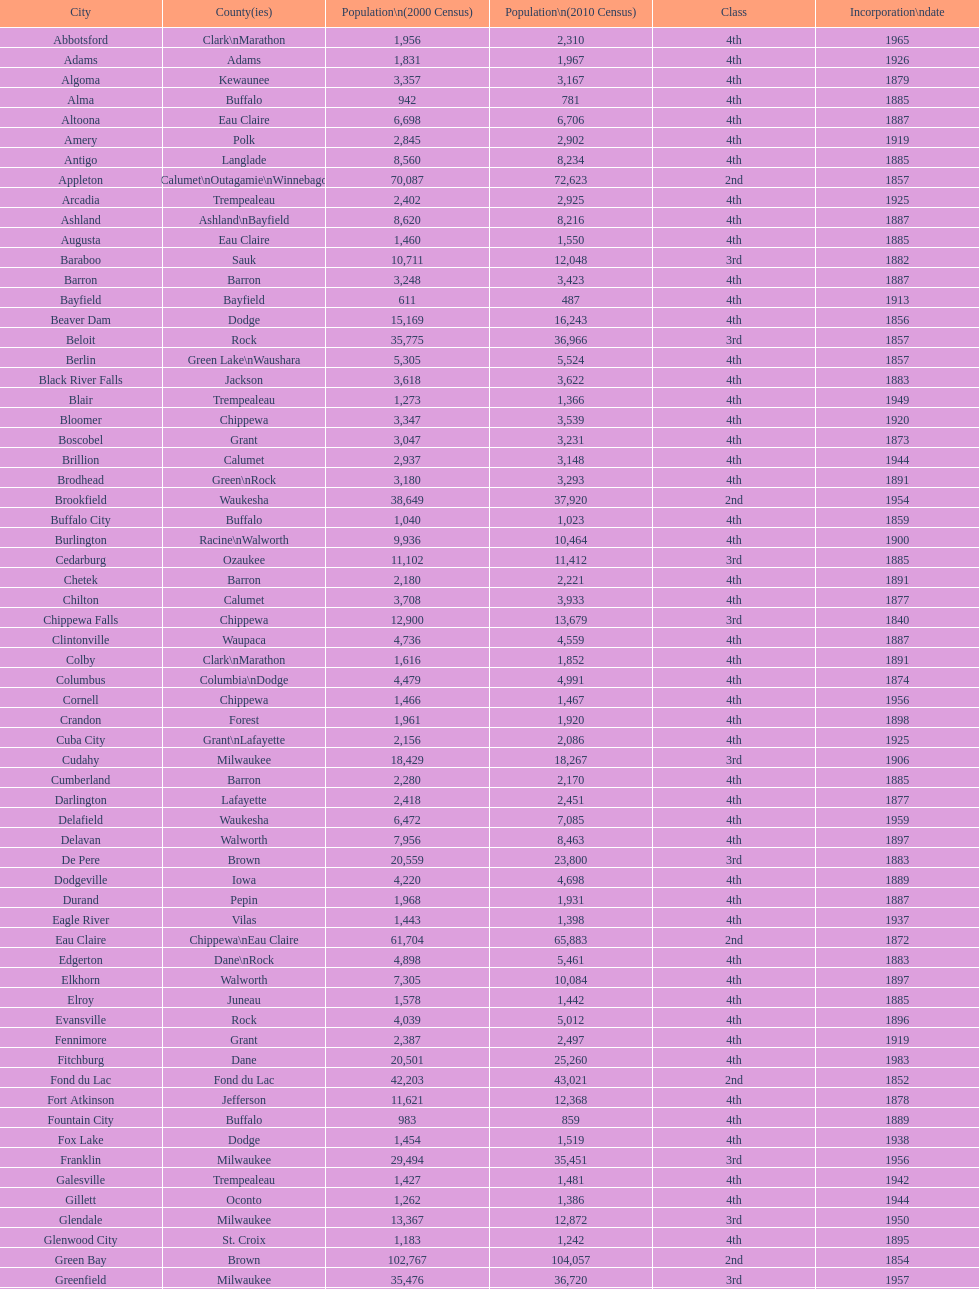Would you mind parsing the complete table? {'header': ['City', 'County(ies)', 'Population\\n(2000 Census)', 'Population\\n(2010 Census)', 'Class', 'Incorporation\\ndate'], 'rows': [['Abbotsford', 'Clark\\nMarathon', '1,956', '2,310', '4th', '1965'], ['Adams', 'Adams', '1,831', '1,967', '4th', '1926'], ['Algoma', 'Kewaunee', '3,357', '3,167', '4th', '1879'], ['Alma', 'Buffalo', '942', '781', '4th', '1885'], ['Altoona', 'Eau Claire', '6,698', '6,706', '4th', '1887'], ['Amery', 'Polk', '2,845', '2,902', '4th', '1919'], ['Antigo', 'Langlade', '8,560', '8,234', '4th', '1885'], ['Appleton', 'Calumet\\nOutagamie\\nWinnebago', '70,087', '72,623', '2nd', '1857'], ['Arcadia', 'Trempealeau', '2,402', '2,925', '4th', '1925'], ['Ashland', 'Ashland\\nBayfield', '8,620', '8,216', '4th', '1887'], ['Augusta', 'Eau Claire', '1,460', '1,550', '4th', '1885'], ['Baraboo', 'Sauk', '10,711', '12,048', '3rd', '1882'], ['Barron', 'Barron', '3,248', '3,423', '4th', '1887'], ['Bayfield', 'Bayfield', '611', '487', '4th', '1913'], ['Beaver Dam', 'Dodge', '15,169', '16,243', '4th', '1856'], ['Beloit', 'Rock', '35,775', '36,966', '3rd', '1857'], ['Berlin', 'Green Lake\\nWaushara', '5,305', '5,524', '4th', '1857'], ['Black River Falls', 'Jackson', '3,618', '3,622', '4th', '1883'], ['Blair', 'Trempealeau', '1,273', '1,366', '4th', '1949'], ['Bloomer', 'Chippewa', '3,347', '3,539', '4th', '1920'], ['Boscobel', 'Grant', '3,047', '3,231', '4th', '1873'], ['Brillion', 'Calumet', '2,937', '3,148', '4th', '1944'], ['Brodhead', 'Green\\nRock', '3,180', '3,293', '4th', '1891'], ['Brookfield', 'Waukesha', '38,649', '37,920', '2nd', '1954'], ['Buffalo City', 'Buffalo', '1,040', '1,023', '4th', '1859'], ['Burlington', 'Racine\\nWalworth', '9,936', '10,464', '4th', '1900'], ['Cedarburg', 'Ozaukee', '11,102', '11,412', '3rd', '1885'], ['Chetek', 'Barron', '2,180', '2,221', '4th', '1891'], ['Chilton', 'Calumet', '3,708', '3,933', '4th', '1877'], ['Chippewa Falls', 'Chippewa', '12,900', '13,679', '3rd', '1840'], ['Clintonville', 'Waupaca', '4,736', '4,559', '4th', '1887'], ['Colby', 'Clark\\nMarathon', '1,616', '1,852', '4th', '1891'], ['Columbus', 'Columbia\\nDodge', '4,479', '4,991', '4th', '1874'], ['Cornell', 'Chippewa', '1,466', '1,467', '4th', '1956'], ['Crandon', 'Forest', '1,961', '1,920', '4th', '1898'], ['Cuba City', 'Grant\\nLafayette', '2,156', '2,086', '4th', '1925'], ['Cudahy', 'Milwaukee', '18,429', '18,267', '3rd', '1906'], ['Cumberland', 'Barron', '2,280', '2,170', '4th', '1885'], ['Darlington', 'Lafayette', '2,418', '2,451', '4th', '1877'], ['Delafield', 'Waukesha', '6,472', '7,085', '4th', '1959'], ['Delavan', 'Walworth', '7,956', '8,463', '4th', '1897'], ['De Pere', 'Brown', '20,559', '23,800', '3rd', '1883'], ['Dodgeville', 'Iowa', '4,220', '4,698', '4th', '1889'], ['Durand', 'Pepin', '1,968', '1,931', '4th', '1887'], ['Eagle River', 'Vilas', '1,443', '1,398', '4th', '1937'], ['Eau Claire', 'Chippewa\\nEau Claire', '61,704', '65,883', '2nd', '1872'], ['Edgerton', 'Dane\\nRock', '4,898', '5,461', '4th', '1883'], ['Elkhorn', 'Walworth', '7,305', '10,084', '4th', '1897'], ['Elroy', 'Juneau', '1,578', '1,442', '4th', '1885'], ['Evansville', 'Rock', '4,039', '5,012', '4th', '1896'], ['Fennimore', 'Grant', '2,387', '2,497', '4th', '1919'], ['Fitchburg', 'Dane', '20,501', '25,260', '4th', '1983'], ['Fond du Lac', 'Fond du Lac', '42,203', '43,021', '2nd', '1852'], ['Fort Atkinson', 'Jefferson', '11,621', '12,368', '4th', '1878'], ['Fountain City', 'Buffalo', '983', '859', '4th', '1889'], ['Fox Lake', 'Dodge', '1,454', '1,519', '4th', '1938'], ['Franklin', 'Milwaukee', '29,494', '35,451', '3rd', '1956'], ['Galesville', 'Trempealeau', '1,427', '1,481', '4th', '1942'], ['Gillett', 'Oconto', '1,262', '1,386', '4th', '1944'], ['Glendale', 'Milwaukee', '13,367', '12,872', '3rd', '1950'], ['Glenwood City', 'St. Croix', '1,183', '1,242', '4th', '1895'], ['Green Bay', 'Brown', '102,767', '104,057', '2nd', '1854'], ['Greenfield', 'Milwaukee', '35,476', '36,720', '3rd', '1957'], ['Green Lake', 'Green Lake', '1,100', '960', '4th', '1962'], ['Greenwood', 'Clark', '1,079', '1,026', '4th', '1891'], ['Hartford', 'Dodge\\nWashington', '10,905', '14,223', '3rd', '1883'], ['Hayward', 'Sawyer', '2,129', '2,318', '4th', '1915'], ['Hillsboro', 'Vernon', '1,302', '1,417', '4th', '1885'], ['Horicon', 'Dodge', '3,775', '3,655', '4th', '1897'], ['Hudson', 'St. Croix', '8,775', '12,719', '4th', '1858'], ['Hurley', 'Iron', '1,818', '1,547', '4th', '1918'], ['Independence', 'Trempealeau', '1,244', '1,336', '4th', '1942'], ['Janesville', 'Rock', '59,498', '63,575', '2nd', '1853'], ['Jefferson', 'Jefferson', '7,338', '7,973', '4th', '1878'], ['Juneau', 'Dodge', '2,485', '2,814', '4th', '1887'], ['Kaukauna', 'Outagamie', '12,983', '15,462', '3rd', '1885'], ['Kenosha', 'Kenosha', '90,352', '99,218', '2nd', '1850'], ['Kewaunee', 'Kewaunee', '2,806', '2,952', '4th', '1883'], ['Kiel', 'Calumet\\nManitowoc', '3,450', '3,738', '4th', '1920'], ['La Crosse', 'La Crosse', '51,818', '51,320', '2nd', '1856'], ['Ladysmith', 'Rusk', '3,932', '3,414', '4th', '1905'], ['Lake Geneva', 'Walworth', '7,148', '7,651', '4th', '1883'], ['Lake Mills', 'Jefferson', '4,843', '5,708', '4th', '1905'], ['Lancaster', 'Grant', '4,070', '3,868', '4th', '1878'], ['Lodi', 'Columbia', '2,882', '3,050', '4th', '1941'], ['Loyal', 'Clark', '1,308', '1,261', '4th', '1948'], ['Madison', 'Dane', '208,054', '233,209', '2nd', '1856'], ['Manawa', 'Waupaca', '1,330', '1,371', '4th', '1954'], ['Manitowoc', 'Manitowoc', '34,053', '33,736', '3rd', '1870'], ['Marinette', 'Marinette', '11,749', '10,968', '3rd', '1887'], ['Marion', 'Shawano\\nWaupaca', '1,297', '1,260', '4th', '1898'], ['Markesan', 'Green Lake', '1,396', '1,476', '4th', '1959'], ['Marshfield', 'Marathon\\nWood', '18,800', '19,118', '3rd', '1883'], ['Mauston', 'Juneau', '3,740', '4,423', '4th', '1883'], ['Mayville', 'Dodge', '4,902', '5,154', '4th', '1885'], ['Medford', 'Taylor', '4,350', '4,326', '4th', '1889'], ['Mellen', 'Ashland', '845', '731', '4th', '1907'], ['Menasha', 'Calumet\\nWinnebago', '16,331', '17,353', '3rd', '1874'], ['Menomonie', 'Dunn', '14,937', '16,264', '4th', '1882'], ['Mequon', 'Ozaukee', '22,643', '23,132', '4th', '1957'], ['Merrill', 'Lincoln', '10,146', '9,661', '4th', '1883'], ['Middleton', 'Dane', '15,770', '17,442', '3rd', '1963'], ['Milton', 'Rock', '5,132', '5,546', '4th', '1969'], ['Milwaukee', 'Milwaukee\\nWashington\\nWaukesha', '596,974', '594,833', '1st', '1846'], ['Mineral Point', 'Iowa', '2,617', '2,487', '4th', '1857'], ['Mondovi', 'Buffalo', '2,634', '2,777', '4th', '1889'], ['Monona', 'Dane', '8,018', '7,533', '4th', '1969'], ['Monroe', 'Green', '10,843', '10,827', '4th', '1882'], ['Montello', 'Marquette', '1,397', '1,495', '4th', '1938'], ['Montreal', 'Iron', '838', '807', '4th', '1924'], ['Mosinee', 'Marathon', '4,063', '3,988', '4th', '1931'], ['Muskego', 'Waukesha', '21,397', '24,135', '3rd', '1964'], ['Neenah', 'Winnebago', '24,507', '25,501', '3rd', '1873'], ['Neillsville', 'Clark', '2,731', '2,463', '4th', '1882'], ['Nekoosa', 'Wood', '2,590', '2,580', '4th', '1926'], ['New Berlin', 'Waukesha', '38,220', '39,584', '3rd', '1959'], ['New Holstein', 'Calumet', '3,301', '3,236', '4th', '1889'], ['New Lisbon', 'Juneau', '1,436', '2,554', '4th', '1889'], ['New London', 'Outagamie\\nWaupaca', '7,085', '7,295', '4th', '1877'], ['New Richmond', 'St. Croix', '6,310', '8,375', '4th', '1885'], ['Niagara', 'Marinette', '1,880', '1,624', '4th', '1992'], ['Oak Creek', 'Milwaukee', '28,456', '34,451', '3rd', '1955'], ['Oconomowoc', 'Waukesha', '12,382', '15,712', '3rd', '1875'], ['Oconto', 'Oconto', '4,708', '4,513', '4th', '1869'], ['Oconto Falls', 'Oconto', '2,843', '2,891', '4th', '1919'], ['Omro', 'Winnebago', '3,177', '3,517', '4th', '1944'], ['Onalaska', 'La Crosse', '14,839', '17,736', '4th', '1887'], ['Oshkosh', 'Winnebago', '62,916', '66,083', '2nd', '1853'], ['Osseo', 'Trempealeau', '1,669', '1,701', '4th', '1941'], ['Owen', 'Clark', '936', '940', '4th', '1925'], ['Park Falls', 'Price', '2,739', '2,462', '4th', '1912'], ['Peshtigo', 'Marinette', '3,474', '3,502', '4th', '1903'], ['Pewaukee', 'Waukesha', '11,783', '13,195', '3rd', '1999'], ['Phillips', 'Price', '1,675', '1,478', '4th', '1891'], ['Pittsville', 'Wood', '866', '874', '4th', '1887'], ['Platteville', 'Grant', '9,989', '11,224', '4th', '1876'], ['Plymouth', 'Sheboygan', '7,781', '8,445', '4th', '1877'], ['Port Washington', 'Ozaukee', '10,467', '11,250', '4th', '1882'], ['Portage', 'Columbia', '9,728', '10,324', '4th', '1854'], ['Prairie du Chien', 'Crawford', '6,018', '5,911', '4th', '1872'], ['Prescott', 'Pierce', '3,764', '4,258', '4th', '1857'], ['Princeton', 'Green Lake', '1,504', '1,214', '4th', '1920'], ['Racine', 'Racine', '81,855', '78,860', '2nd', '1848'], ['Reedsburg', 'Sauk', '7,827', '10,014', '4th', '1887'], ['Rhinelander', 'Oneida', '7,735', '7,798', '4th', '1894'], ['Rice Lake', 'Barron', '8,312', '8,438', '4th', '1887'], ['Richland Center', 'Richland', '5,114', '5,184', '4th', '1887'], ['Ripon', 'Fond du Lac', '7,450', '7,733', '4th', '1858'], ['River Falls', 'Pierce\\nSt. Croix', '12,560', '15,000', '3rd', '1875'], ['St. Croix Falls', 'Polk', '2,033', '2,133', '4th', '1958'], ['St. Francis', 'Milwaukee', '8,662', '9,365', '4th', '1951'], ['Schofield', 'Marathon', '2,117', '2,169', '4th', '1951'], ['Seymour', 'Outagamie', '3,335', '3,451', '4th', '1879'], ['Shawano', 'Shawano', '8,298', '9,305', '4th', '1874'], ['Sheboygan', 'Sheboygan', '50,792', '49,288', '2nd', '1853'], ['Sheboygan Falls', 'Sheboygan', '6,772', '7,775', '4th', '1913'], ['Shell Lake', 'Washburn', '1,309', '1,347', '4th', '1961'], ['Shullsburg', 'Lafayette', '1,246', '1,226', '4th', '1889'], ['South Milwaukee', 'Milwaukee', '21,256', '21,156', '4th', '1897'], ['Sparta', 'Monroe', '8,648', '9,522', '4th', '1883'], ['Spooner', 'Washburn', '2,653', '2,682', '4th', '1909'], ['Stanley', 'Chippewa\\nClark', '1,898', '3,608', '4th', '1898'], ['Stevens Point', 'Portage', '24,551', '26,717', '3rd', '1858'], ['Stoughton', 'Dane', '12,354', '12,611', '4th', '1882'], ['Sturgeon Bay', 'Door', '9,437', '9,144', '4th', '1883'], ['Sun Prairie', 'Dane', '20,369', '29,364', '3rd', '1958'], ['Superior', 'Douglas', '27,368', '27,244', '2nd', '1858'], ['Thorp', 'Clark', '1,536', '1,621', '4th', '1948'], ['Tomah', 'Monroe', '8,419', '9,093', '4th', '1883'], ['Tomahawk', 'Lincoln', '3,770', '3,397', '4th', '1891'], ['Two Rivers', 'Manitowoc', '12,639', '11,712', '3rd', '1878'], ['Verona', 'Dane', '7,052', '10,619', '4th', '1977'], ['Viroqua', 'Vernon', '4,335', '5,079', '4th', '1885'], ['Washburn', 'Bayfield', '2,280', '2,117', '4th', '1904'], ['Waterloo', 'Jefferson', '3,259', '3,333', '4th', '1962'], ['Watertown', 'Dodge\\nJefferson', '21,598', '23,861', '3rd', '1853'], ['Waukesha', 'Waukesha', '64,825', '70,718', '2nd', '1895'], ['Waupaca', 'Waupaca', '5,676', '6,069', '4th', '1878'], ['Waupun', 'Dodge\\nFond du Lac', '10,944', '11,340', '4th', '1878'], ['Wausau', 'Marathon', '38,426', '39,106', '3rd', '1872'], ['Wautoma', 'Waushara', '1,998', '2,218', '4th', '1901'], ['Wauwatosa', 'Milwaukee', '47,271', '46,396', '2nd', '1897'], ['West Allis', 'Milwaukee', '61,254', '60,411', '2nd', '1906'], ['West Bend', 'Washington', '28,152', '31,078', '3rd', '1885'], ['Westby', 'Vernon', '2,045', '2,200', '4th', '1920'], ['Weyauwega', 'Waupaca', '1,806', '1,900', '4th', '1939'], ['Whitehall', 'Trempealeau', '1,651', '1,558', '4th', '1941'], ['Whitewater', 'Jefferson\\nWalworth', '13,437', '14,390', '4th', '1885'], ['Wisconsin Dells', 'Adams\\nColumbia\\nJuneau\\nSauk', '2,418', '2,678', '4th', '1925'], ['Wisconsin Rapids', 'Wood', '18,435', '18,367', '3rd', '1869']]} Are both altoona and augusta located within the county? Eau Claire. 